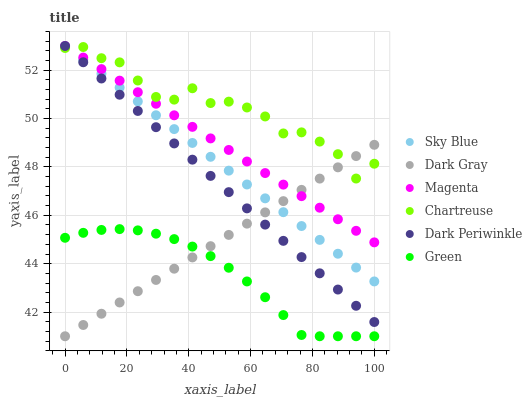Does Green have the minimum area under the curve?
Answer yes or no. Yes. Does Chartreuse have the maximum area under the curve?
Answer yes or no. Yes. Does Chartreuse have the minimum area under the curve?
Answer yes or no. No. Does Green have the maximum area under the curve?
Answer yes or no. No. Is Magenta the smoothest?
Answer yes or no. Yes. Is Chartreuse the roughest?
Answer yes or no. Yes. Is Green the smoothest?
Answer yes or no. No. Is Green the roughest?
Answer yes or no. No. Does Dark Gray have the lowest value?
Answer yes or no. Yes. Does Chartreuse have the lowest value?
Answer yes or no. No. Does Dark Periwinkle have the highest value?
Answer yes or no. Yes. Does Chartreuse have the highest value?
Answer yes or no. No. Is Green less than Sky Blue?
Answer yes or no. Yes. Is Dark Periwinkle greater than Green?
Answer yes or no. Yes. Does Sky Blue intersect Dark Periwinkle?
Answer yes or no. Yes. Is Sky Blue less than Dark Periwinkle?
Answer yes or no. No. Is Sky Blue greater than Dark Periwinkle?
Answer yes or no. No. Does Green intersect Sky Blue?
Answer yes or no. No. 